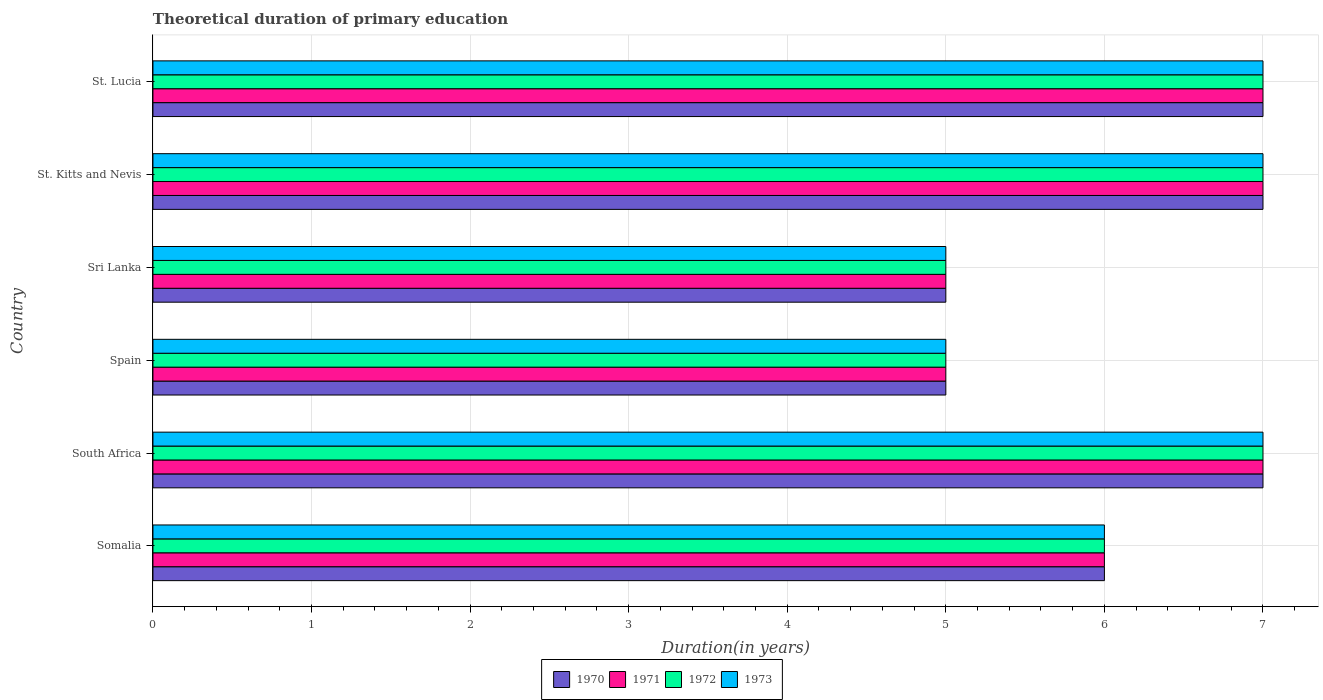How many groups of bars are there?
Your response must be concise. 6. Are the number of bars on each tick of the Y-axis equal?
Your answer should be compact. Yes. How many bars are there on the 5th tick from the top?
Offer a terse response. 4. How many bars are there on the 2nd tick from the bottom?
Provide a succinct answer. 4. What is the label of the 5th group of bars from the top?
Give a very brief answer. South Africa. Across all countries, what is the minimum total theoretical duration of primary education in 1971?
Ensure brevity in your answer.  5. In which country was the total theoretical duration of primary education in 1972 maximum?
Provide a succinct answer. South Africa. What is the total total theoretical duration of primary education in 1970 in the graph?
Offer a terse response. 37. What is the average total theoretical duration of primary education in 1970 per country?
Provide a succinct answer. 6.17. What is the difference between the total theoretical duration of primary education in 1973 and total theoretical duration of primary education in 1972 in South Africa?
Provide a succinct answer. 0. In how many countries, is the total theoretical duration of primary education in 1971 greater than 0.4 years?
Make the answer very short. 6. What is the ratio of the total theoretical duration of primary education in 1971 in Spain to that in St. Lucia?
Provide a short and direct response. 0.71. What is the difference between the highest and the lowest total theoretical duration of primary education in 1971?
Provide a succinct answer. 2. In how many countries, is the total theoretical duration of primary education in 1971 greater than the average total theoretical duration of primary education in 1971 taken over all countries?
Keep it short and to the point. 3. Is the sum of the total theoretical duration of primary education in 1970 in Spain and Sri Lanka greater than the maximum total theoretical duration of primary education in 1972 across all countries?
Provide a succinct answer. Yes. What does the 4th bar from the bottom in South Africa represents?
Ensure brevity in your answer.  1973. How many bars are there?
Provide a succinct answer. 24. How many countries are there in the graph?
Your response must be concise. 6. Does the graph contain any zero values?
Provide a succinct answer. No. Where does the legend appear in the graph?
Your answer should be compact. Bottom center. How many legend labels are there?
Keep it short and to the point. 4. How are the legend labels stacked?
Your answer should be compact. Horizontal. What is the title of the graph?
Your answer should be very brief. Theoretical duration of primary education. What is the label or title of the X-axis?
Give a very brief answer. Duration(in years). What is the Duration(in years) in 1971 in Somalia?
Keep it short and to the point. 6. What is the Duration(in years) in 1971 in South Africa?
Give a very brief answer. 7. What is the Duration(in years) in 1972 in South Africa?
Offer a terse response. 7. What is the Duration(in years) of 1973 in South Africa?
Provide a short and direct response. 7. What is the Duration(in years) in 1971 in Spain?
Make the answer very short. 5. What is the Duration(in years) of 1972 in Spain?
Provide a succinct answer. 5. What is the Duration(in years) of 1970 in Sri Lanka?
Your answer should be compact. 5. What is the Duration(in years) of 1972 in Sri Lanka?
Give a very brief answer. 5. What is the Duration(in years) in 1973 in Sri Lanka?
Ensure brevity in your answer.  5. What is the Duration(in years) in 1971 in St. Kitts and Nevis?
Provide a short and direct response. 7. What is the Duration(in years) of 1972 in St. Kitts and Nevis?
Your answer should be compact. 7. What is the Duration(in years) of 1970 in St. Lucia?
Your answer should be very brief. 7. What is the Duration(in years) in 1972 in St. Lucia?
Provide a succinct answer. 7. Across all countries, what is the maximum Duration(in years) in 1970?
Provide a short and direct response. 7. Across all countries, what is the maximum Duration(in years) in 1972?
Ensure brevity in your answer.  7. Across all countries, what is the minimum Duration(in years) of 1972?
Keep it short and to the point. 5. What is the total Duration(in years) of 1970 in the graph?
Your answer should be compact. 37. What is the difference between the Duration(in years) in 1971 in Somalia and that in South Africa?
Make the answer very short. -1. What is the difference between the Duration(in years) of 1970 in Somalia and that in Spain?
Your answer should be very brief. 1. What is the difference between the Duration(in years) in 1971 in Somalia and that in Sri Lanka?
Provide a succinct answer. 1. What is the difference between the Duration(in years) of 1972 in Somalia and that in Sri Lanka?
Give a very brief answer. 1. What is the difference between the Duration(in years) in 1973 in Somalia and that in Sri Lanka?
Your answer should be compact. 1. What is the difference between the Duration(in years) of 1970 in Somalia and that in St. Kitts and Nevis?
Give a very brief answer. -1. What is the difference between the Duration(in years) of 1972 in Somalia and that in St. Kitts and Nevis?
Your response must be concise. -1. What is the difference between the Duration(in years) of 1973 in Somalia and that in St. Kitts and Nevis?
Ensure brevity in your answer.  -1. What is the difference between the Duration(in years) of 1970 in Somalia and that in St. Lucia?
Provide a short and direct response. -1. What is the difference between the Duration(in years) in 1971 in Somalia and that in St. Lucia?
Your answer should be compact. -1. What is the difference between the Duration(in years) in 1971 in South Africa and that in Spain?
Keep it short and to the point. 2. What is the difference between the Duration(in years) of 1970 in South Africa and that in Sri Lanka?
Keep it short and to the point. 2. What is the difference between the Duration(in years) of 1971 in South Africa and that in Sri Lanka?
Keep it short and to the point. 2. What is the difference between the Duration(in years) in 1972 in South Africa and that in Sri Lanka?
Make the answer very short. 2. What is the difference between the Duration(in years) in 1970 in South Africa and that in St. Kitts and Nevis?
Provide a succinct answer. 0. What is the difference between the Duration(in years) of 1971 in South Africa and that in St. Kitts and Nevis?
Give a very brief answer. 0. What is the difference between the Duration(in years) in 1972 in South Africa and that in St. Kitts and Nevis?
Make the answer very short. 0. What is the difference between the Duration(in years) of 1972 in South Africa and that in St. Lucia?
Your answer should be compact. 0. What is the difference between the Duration(in years) of 1970 in Spain and that in Sri Lanka?
Give a very brief answer. 0. What is the difference between the Duration(in years) of 1972 in Spain and that in Sri Lanka?
Provide a short and direct response. 0. What is the difference between the Duration(in years) in 1973 in Spain and that in Sri Lanka?
Make the answer very short. 0. What is the difference between the Duration(in years) of 1973 in Spain and that in St. Lucia?
Provide a succinct answer. -2. What is the difference between the Duration(in years) of 1970 in Sri Lanka and that in St. Kitts and Nevis?
Offer a very short reply. -2. What is the difference between the Duration(in years) in 1971 in Sri Lanka and that in St. Kitts and Nevis?
Provide a succinct answer. -2. What is the difference between the Duration(in years) of 1970 in Sri Lanka and that in St. Lucia?
Provide a succinct answer. -2. What is the difference between the Duration(in years) of 1971 in Sri Lanka and that in St. Lucia?
Keep it short and to the point. -2. What is the difference between the Duration(in years) of 1973 in Sri Lanka and that in St. Lucia?
Make the answer very short. -2. What is the difference between the Duration(in years) in 1970 in St. Kitts and Nevis and that in St. Lucia?
Your answer should be compact. 0. What is the difference between the Duration(in years) in 1971 in St. Kitts and Nevis and that in St. Lucia?
Provide a short and direct response. 0. What is the difference between the Duration(in years) in 1970 in Somalia and the Duration(in years) in 1971 in South Africa?
Provide a succinct answer. -1. What is the difference between the Duration(in years) of 1970 in Somalia and the Duration(in years) of 1972 in South Africa?
Provide a short and direct response. -1. What is the difference between the Duration(in years) of 1970 in Somalia and the Duration(in years) of 1973 in South Africa?
Offer a very short reply. -1. What is the difference between the Duration(in years) in 1972 in Somalia and the Duration(in years) in 1973 in South Africa?
Give a very brief answer. -1. What is the difference between the Duration(in years) of 1970 in Somalia and the Duration(in years) of 1971 in Spain?
Give a very brief answer. 1. What is the difference between the Duration(in years) in 1970 in Somalia and the Duration(in years) in 1972 in Spain?
Give a very brief answer. 1. What is the difference between the Duration(in years) in 1970 in Somalia and the Duration(in years) in 1973 in Spain?
Give a very brief answer. 1. What is the difference between the Duration(in years) of 1971 in Somalia and the Duration(in years) of 1972 in Spain?
Your answer should be compact. 1. What is the difference between the Duration(in years) of 1970 in Somalia and the Duration(in years) of 1971 in Sri Lanka?
Offer a terse response. 1. What is the difference between the Duration(in years) of 1970 in Somalia and the Duration(in years) of 1973 in Sri Lanka?
Your answer should be very brief. 1. What is the difference between the Duration(in years) of 1971 in Somalia and the Duration(in years) of 1973 in Sri Lanka?
Your answer should be compact. 1. What is the difference between the Duration(in years) of 1970 in Somalia and the Duration(in years) of 1972 in St. Kitts and Nevis?
Provide a short and direct response. -1. What is the difference between the Duration(in years) of 1970 in Somalia and the Duration(in years) of 1973 in St. Kitts and Nevis?
Provide a succinct answer. -1. What is the difference between the Duration(in years) of 1971 in Somalia and the Duration(in years) of 1972 in St. Kitts and Nevis?
Your answer should be compact. -1. What is the difference between the Duration(in years) in 1972 in Somalia and the Duration(in years) in 1973 in St. Kitts and Nevis?
Your answer should be compact. -1. What is the difference between the Duration(in years) in 1970 in Somalia and the Duration(in years) in 1972 in St. Lucia?
Provide a succinct answer. -1. What is the difference between the Duration(in years) of 1971 in Somalia and the Duration(in years) of 1972 in St. Lucia?
Your answer should be very brief. -1. What is the difference between the Duration(in years) in 1971 in Somalia and the Duration(in years) in 1973 in St. Lucia?
Provide a short and direct response. -1. What is the difference between the Duration(in years) of 1972 in Somalia and the Duration(in years) of 1973 in St. Lucia?
Ensure brevity in your answer.  -1. What is the difference between the Duration(in years) of 1970 in South Africa and the Duration(in years) of 1971 in Spain?
Provide a short and direct response. 2. What is the difference between the Duration(in years) in 1971 in South Africa and the Duration(in years) in 1972 in Spain?
Offer a terse response. 2. What is the difference between the Duration(in years) in 1971 in South Africa and the Duration(in years) in 1973 in Spain?
Make the answer very short. 2. What is the difference between the Duration(in years) in 1972 in South Africa and the Duration(in years) in 1973 in Spain?
Your answer should be compact. 2. What is the difference between the Duration(in years) of 1970 in South Africa and the Duration(in years) of 1973 in Sri Lanka?
Your response must be concise. 2. What is the difference between the Duration(in years) in 1971 in South Africa and the Duration(in years) in 1973 in Sri Lanka?
Ensure brevity in your answer.  2. What is the difference between the Duration(in years) in 1970 in South Africa and the Duration(in years) in 1972 in St. Kitts and Nevis?
Your response must be concise. 0. What is the difference between the Duration(in years) of 1971 in South Africa and the Duration(in years) of 1972 in St. Kitts and Nevis?
Your answer should be very brief. 0. What is the difference between the Duration(in years) of 1970 in South Africa and the Duration(in years) of 1972 in St. Lucia?
Provide a succinct answer. 0. What is the difference between the Duration(in years) of 1971 in South Africa and the Duration(in years) of 1972 in St. Lucia?
Make the answer very short. 0. What is the difference between the Duration(in years) of 1970 in Spain and the Duration(in years) of 1972 in Sri Lanka?
Offer a very short reply. 0. What is the difference between the Duration(in years) in 1970 in Spain and the Duration(in years) in 1973 in St. Kitts and Nevis?
Your response must be concise. -2. What is the difference between the Duration(in years) in 1971 in Spain and the Duration(in years) in 1973 in St. Kitts and Nevis?
Provide a short and direct response. -2. What is the difference between the Duration(in years) in 1970 in Spain and the Duration(in years) in 1973 in St. Lucia?
Offer a terse response. -2. What is the difference between the Duration(in years) in 1971 in Spain and the Duration(in years) in 1972 in St. Lucia?
Keep it short and to the point. -2. What is the difference between the Duration(in years) in 1970 in Sri Lanka and the Duration(in years) in 1971 in St. Kitts and Nevis?
Keep it short and to the point. -2. What is the difference between the Duration(in years) of 1971 in Sri Lanka and the Duration(in years) of 1972 in St. Kitts and Nevis?
Give a very brief answer. -2. What is the difference between the Duration(in years) in 1971 in Sri Lanka and the Duration(in years) in 1973 in St. Kitts and Nevis?
Provide a succinct answer. -2. What is the difference between the Duration(in years) of 1970 in Sri Lanka and the Duration(in years) of 1971 in St. Lucia?
Provide a succinct answer. -2. What is the difference between the Duration(in years) in 1972 in Sri Lanka and the Duration(in years) in 1973 in St. Lucia?
Your answer should be very brief. -2. What is the difference between the Duration(in years) in 1972 in St. Kitts and Nevis and the Duration(in years) in 1973 in St. Lucia?
Make the answer very short. 0. What is the average Duration(in years) in 1970 per country?
Keep it short and to the point. 6.17. What is the average Duration(in years) in 1971 per country?
Keep it short and to the point. 6.17. What is the average Duration(in years) of 1972 per country?
Provide a short and direct response. 6.17. What is the average Duration(in years) of 1973 per country?
Your answer should be compact. 6.17. What is the difference between the Duration(in years) in 1970 and Duration(in years) in 1971 in Somalia?
Offer a terse response. 0. What is the difference between the Duration(in years) of 1971 and Duration(in years) of 1972 in Somalia?
Keep it short and to the point. 0. What is the difference between the Duration(in years) of 1972 and Duration(in years) of 1973 in Somalia?
Provide a short and direct response. 0. What is the difference between the Duration(in years) of 1970 and Duration(in years) of 1972 in South Africa?
Offer a terse response. 0. What is the difference between the Duration(in years) in 1970 and Duration(in years) in 1973 in South Africa?
Make the answer very short. 0. What is the difference between the Duration(in years) in 1971 and Duration(in years) in 1973 in South Africa?
Provide a succinct answer. 0. What is the difference between the Duration(in years) in 1972 and Duration(in years) in 1973 in South Africa?
Your answer should be compact. 0. What is the difference between the Duration(in years) in 1970 and Duration(in years) in 1973 in Spain?
Your response must be concise. 0. What is the difference between the Duration(in years) of 1971 and Duration(in years) of 1972 in Spain?
Offer a very short reply. 0. What is the difference between the Duration(in years) of 1971 and Duration(in years) of 1973 in Spain?
Keep it short and to the point. 0. What is the difference between the Duration(in years) of 1972 and Duration(in years) of 1973 in Spain?
Make the answer very short. 0. What is the difference between the Duration(in years) of 1970 and Duration(in years) of 1971 in Sri Lanka?
Provide a succinct answer. 0. What is the difference between the Duration(in years) in 1970 and Duration(in years) in 1973 in Sri Lanka?
Your answer should be very brief. 0. What is the difference between the Duration(in years) of 1972 and Duration(in years) of 1973 in Sri Lanka?
Offer a terse response. 0. What is the difference between the Duration(in years) of 1970 and Duration(in years) of 1973 in St. Kitts and Nevis?
Keep it short and to the point. 0. What is the difference between the Duration(in years) in 1971 and Duration(in years) in 1973 in St. Kitts and Nevis?
Keep it short and to the point. 0. What is the difference between the Duration(in years) in 1970 and Duration(in years) in 1971 in St. Lucia?
Give a very brief answer. 0. What is the difference between the Duration(in years) of 1970 and Duration(in years) of 1972 in St. Lucia?
Offer a terse response. 0. What is the difference between the Duration(in years) of 1970 and Duration(in years) of 1973 in St. Lucia?
Provide a short and direct response. 0. What is the difference between the Duration(in years) of 1971 and Duration(in years) of 1972 in St. Lucia?
Make the answer very short. 0. What is the difference between the Duration(in years) in 1971 and Duration(in years) in 1973 in St. Lucia?
Make the answer very short. 0. What is the ratio of the Duration(in years) of 1970 in Somalia to that in South Africa?
Offer a very short reply. 0.86. What is the ratio of the Duration(in years) of 1972 in Somalia to that in Spain?
Your response must be concise. 1.2. What is the ratio of the Duration(in years) in 1971 in Somalia to that in Sri Lanka?
Your answer should be compact. 1.2. What is the ratio of the Duration(in years) of 1973 in Somalia to that in Sri Lanka?
Your answer should be compact. 1.2. What is the ratio of the Duration(in years) of 1970 in Somalia to that in St. Kitts and Nevis?
Offer a terse response. 0.86. What is the ratio of the Duration(in years) in 1972 in Somalia to that in St. Kitts and Nevis?
Provide a succinct answer. 0.86. What is the ratio of the Duration(in years) in 1970 in Somalia to that in St. Lucia?
Give a very brief answer. 0.86. What is the ratio of the Duration(in years) of 1971 in Somalia to that in St. Lucia?
Keep it short and to the point. 0.86. What is the ratio of the Duration(in years) in 1972 in Somalia to that in St. Lucia?
Offer a very short reply. 0.86. What is the ratio of the Duration(in years) of 1973 in Somalia to that in St. Lucia?
Your response must be concise. 0.86. What is the ratio of the Duration(in years) of 1970 in South Africa to that in Spain?
Offer a very short reply. 1.4. What is the ratio of the Duration(in years) of 1971 in South Africa to that in Spain?
Your answer should be compact. 1.4. What is the ratio of the Duration(in years) of 1972 in South Africa to that in Spain?
Provide a short and direct response. 1.4. What is the ratio of the Duration(in years) of 1973 in South Africa to that in Spain?
Offer a terse response. 1.4. What is the ratio of the Duration(in years) in 1970 in South Africa to that in Sri Lanka?
Offer a very short reply. 1.4. What is the ratio of the Duration(in years) in 1973 in South Africa to that in St. Kitts and Nevis?
Ensure brevity in your answer.  1. What is the ratio of the Duration(in years) in 1971 in South Africa to that in St. Lucia?
Offer a very short reply. 1. What is the ratio of the Duration(in years) in 1973 in Spain to that in Sri Lanka?
Make the answer very short. 1. What is the ratio of the Duration(in years) of 1972 in Spain to that in St. Kitts and Nevis?
Your answer should be compact. 0.71. What is the ratio of the Duration(in years) in 1973 in Spain to that in St. Lucia?
Your answer should be compact. 0.71. What is the ratio of the Duration(in years) in 1970 in Sri Lanka to that in St. Kitts and Nevis?
Provide a succinct answer. 0.71. What is the ratio of the Duration(in years) in 1971 in Sri Lanka to that in St. Kitts and Nevis?
Offer a very short reply. 0.71. What is the ratio of the Duration(in years) of 1972 in Sri Lanka to that in St. Kitts and Nevis?
Provide a short and direct response. 0.71. What is the ratio of the Duration(in years) in 1973 in Sri Lanka to that in St. Kitts and Nevis?
Provide a short and direct response. 0.71. What is the ratio of the Duration(in years) in 1970 in St. Kitts and Nevis to that in St. Lucia?
Ensure brevity in your answer.  1. What is the ratio of the Duration(in years) of 1971 in St. Kitts and Nevis to that in St. Lucia?
Provide a succinct answer. 1. What is the ratio of the Duration(in years) of 1972 in St. Kitts and Nevis to that in St. Lucia?
Keep it short and to the point. 1. What is the ratio of the Duration(in years) of 1973 in St. Kitts and Nevis to that in St. Lucia?
Keep it short and to the point. 1. What is the difference between the highest and the second highest Duration(in years) of 1970?
Provide a succinct answer. 0. What is the difference between the highest and the second highest Duration(in years) of 1972?
Give a very brief answer. 0. What is the difference between the highest and the second highest Duration(in years) in 1973?
Give a very brief answer. 0. What is the difference between the highest and the lowest Duration(in years) of 1971?
Give a very brief answer. 2. What is the difference between the highest and the lowest Duration(in years) of 1972?
Provide a short and direct response. 2. What is the difference between the highest and the lowest Duration(in years) of 1973?
Your answer should be very brief. 2. 